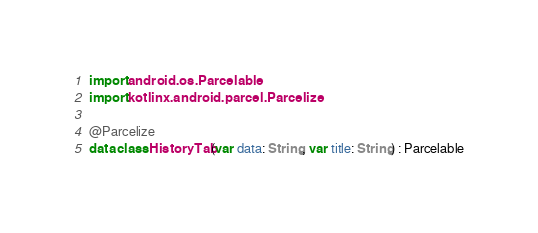Convert code to text. <code><loc_0><loc_0><loc_500><loc_500><_Kotlin_>import android.os.Parcelable
import kotlinx.android.parcel.Parcelize

@Parcelize
data class HistoryTab(var data: String, var title: String) : Parcelable</code> 